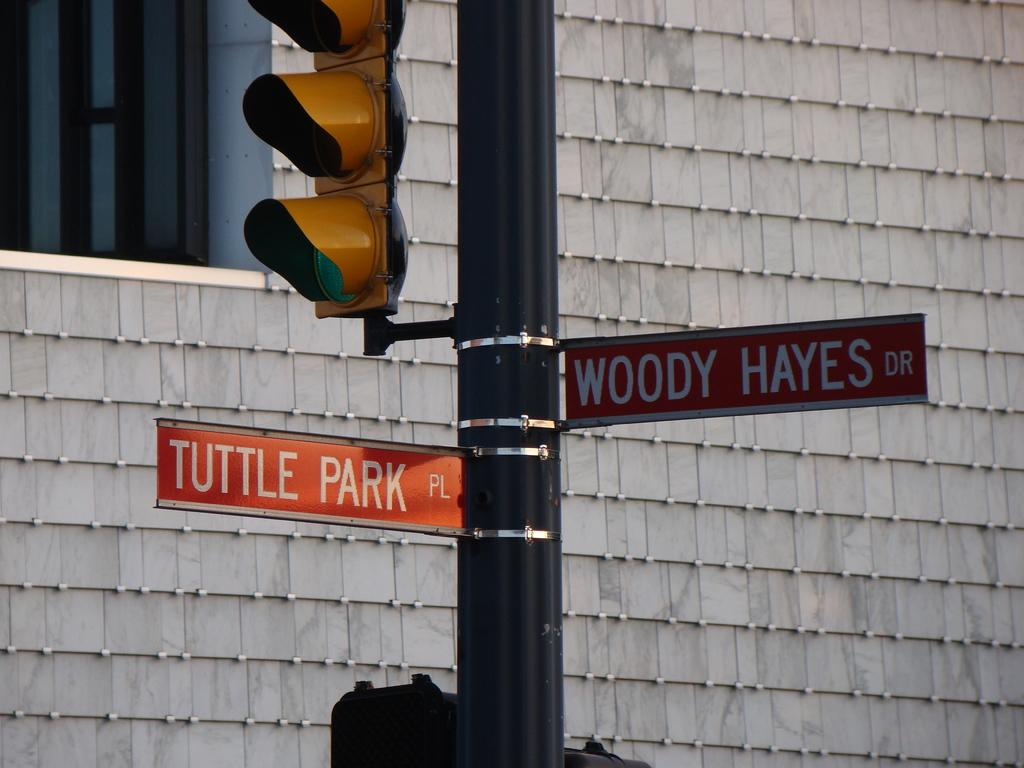<image>
Present a compact description of the photo's key features. A sign pole at a crossing with one sign pointing to Tuttle Park and the other to Woody Hayes Dr 